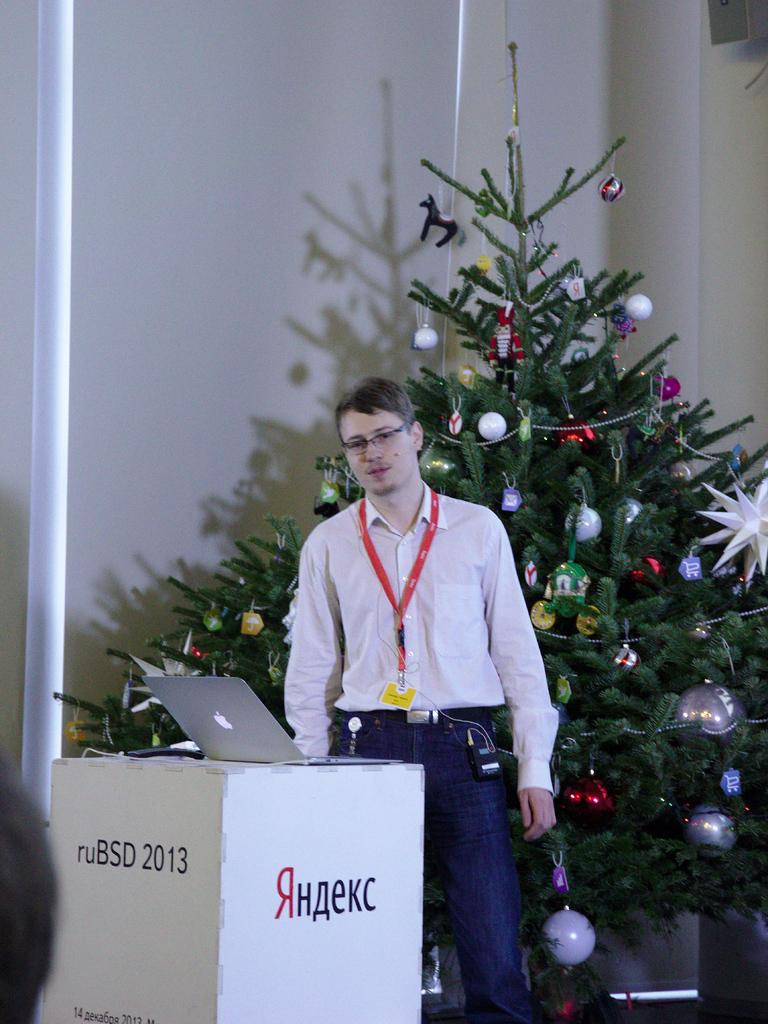Provide a one-sentence caption for the provided image. A man standing in front of a Christmas tree behind a podium about a Russian computer service. 